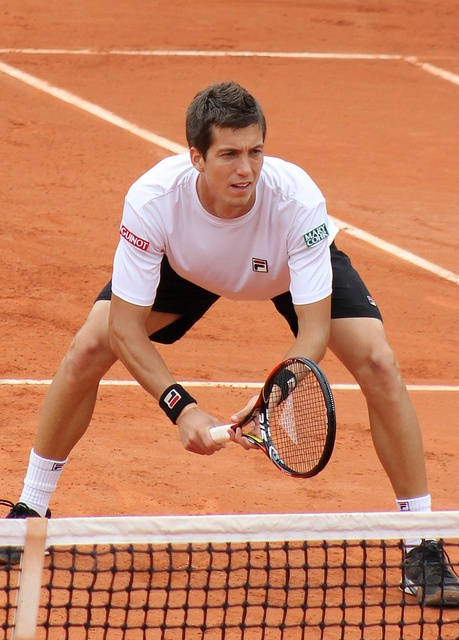Describe the objects in this image and their specific colors. I can see people in salmon, lavender, and black tones and tennis racket in salmon, brown, and black tones in this image. 